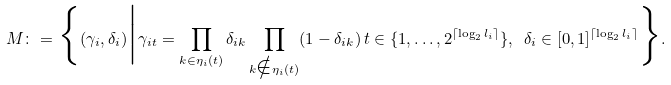<formula> <loc_0><loc_0><loc_500><loc_500>M \colon = \Big \{ ( \gamma _ { i } , \delta _ { i } ) \Big | \gamma _ { i t } = \prod _ { k \in \eta _ { i } ( t ) } \delta _ { i k } \prod _ { k \notin \eta _ { i } ( t ) } ( 1 - \delta _ { i k } ) \, t \in \{ 1 , \dots , 2 ^ { \lceil \log _ { 2 } l _ { i } \rceil } \} , \ \delta _ { i } \in [ 0 , 1 ] ^ { \lceil \log _ { 2 } l _ { i } \rceil } \Big \} .</formula> 